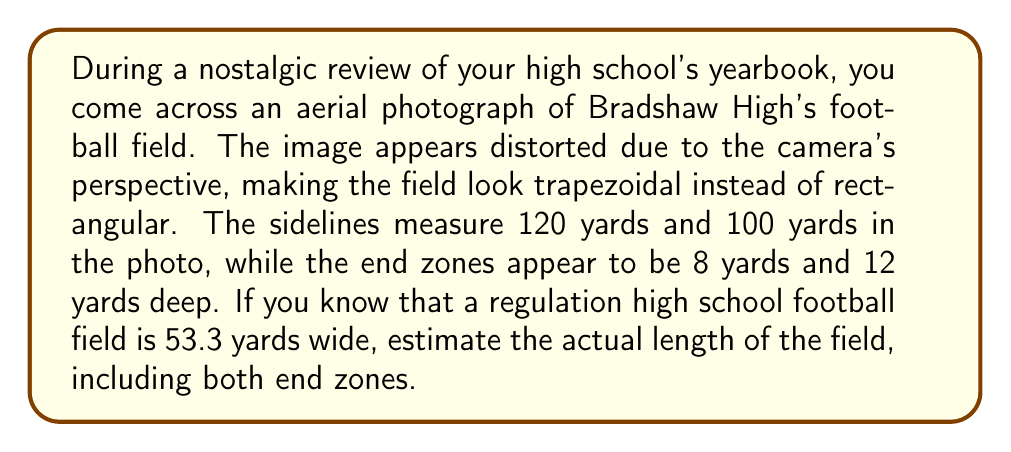Could you help me with this problem? Let's approach this step-by-step:

1) First, we need to understand that the distortion is causing a perspective effect, making one end of the field appear smaller than the other.

2) We know that the actual field is rectangular, so the sidelines should be equal in length. We can use the average of the two given sideline measurements:

   $$(120 + 100) / 2 = 110$$ yards

3) Now, we need to find the scale factor. We know the actual width of a high school football field is 53.3 yards. Let's call our scale factor $s$. Then:

   $$53.3 \cdot s = 110$$
   $$s = 110 / 53.3 \approx 2.0638$$

4) Next, we need to estimate the actual depth of the end zones. We're given 8 yards and 12 yards in the distorted image. Let's average these:

   $$(8 + 12) / 2 = 10$$ yards

5) To get the actual depth of one end zone, we divide by our scale factor:

   $$10 / 2.0638 \approx 4.8455$$ yards

6) A regulation football field is 100 yards long between the end zones. To get the total length, we add this to twice the end zone depth:

   $$100 + (2 \cdot 4.8455) \approx 109.691$$ yards

7) Rounding to the nearest yard gives us 110 yards.
Answer: 110 yards 